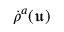Convert formula to latex. <formula><loc_0><loc_0><loc_500><loc_500>\dot { \rho } ^ { a } ( \mathfrak { u } )</formula> 